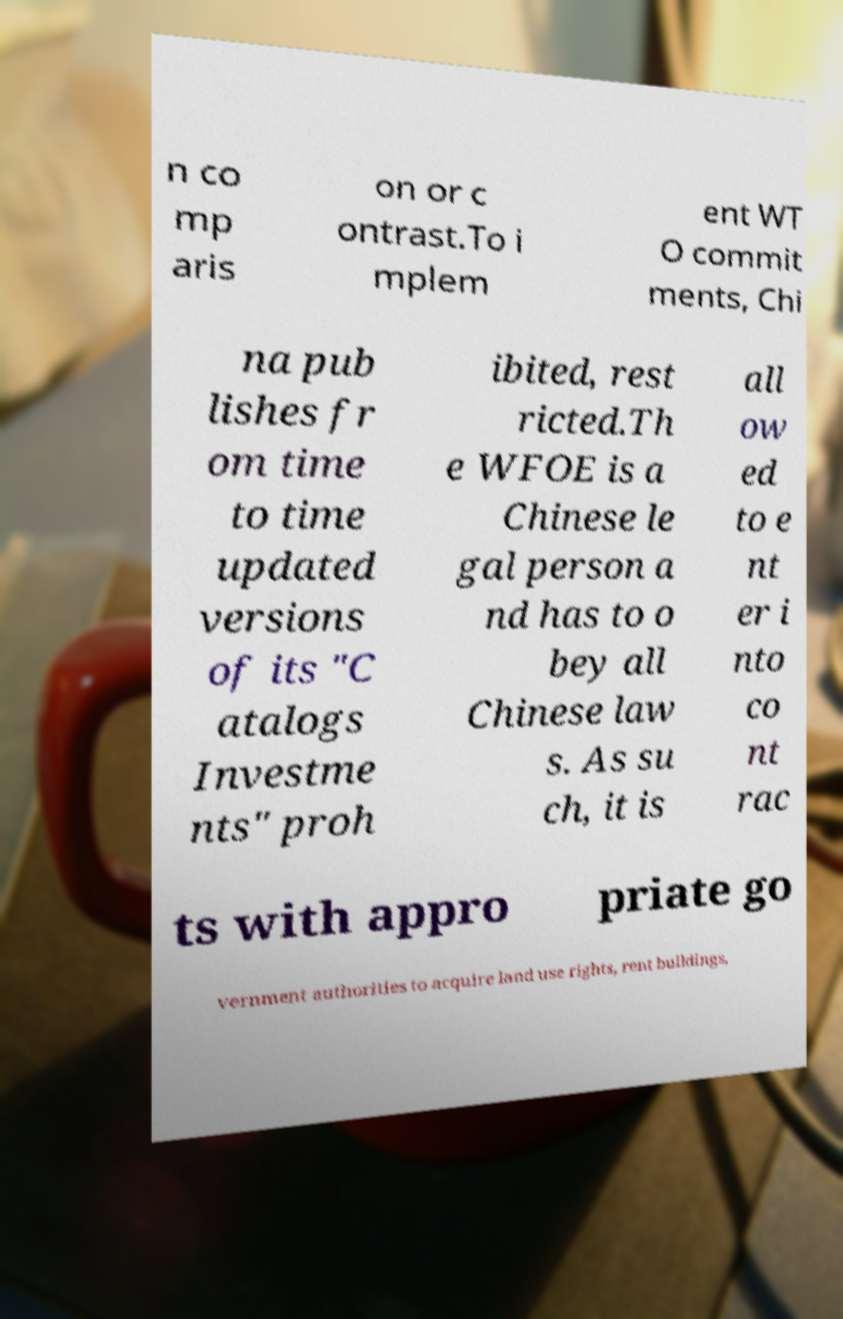There's text embedded in this image that I need extracted. Can you transcribe it verbatim? n co mp aris on or c ontrast.To i mplem ent WT O commit ments, Chi na pub lishes fr om time to time updated versions of its "C atalogs Investme nts" proh ibited, rest ricted.Th e WFOE is a Chinese le gal person a nd has to o bey all Chinese law s. As su ch, it is all ow ed to e nt er i nto co nt rac ts with appro priate go vernment authorities to acquire land use rights, rent buildings, 